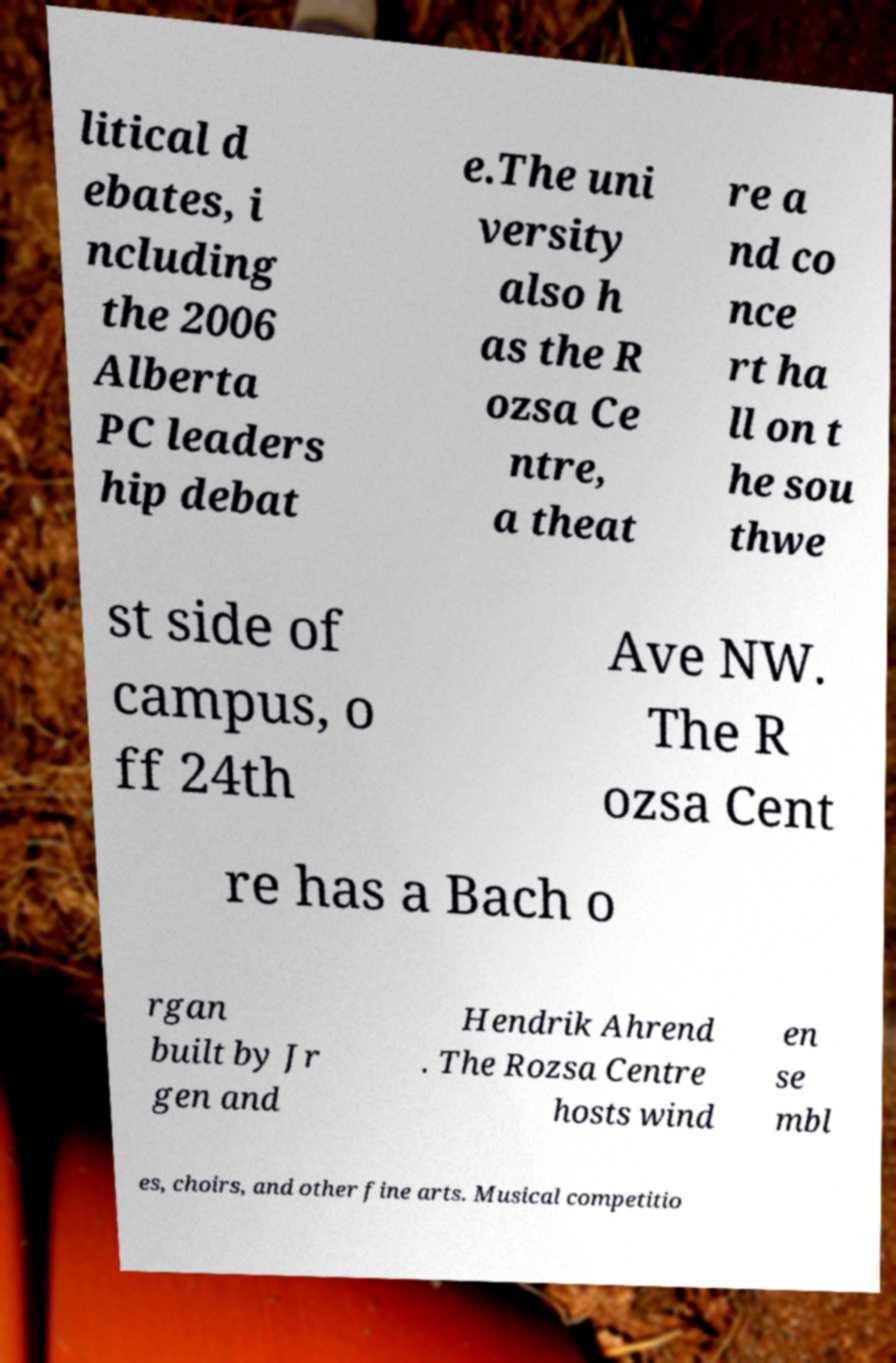Can you accurately transcribe the text from the provided image for me? litical d ebates, i ncluding the 2006 Alberta PC leaders hip debat e.The uni versity also h as the R ozsa Ce ntre, a theat re a nd co nce rt ha ll on t he sou thwe st side of campus, o ff 24th Ave NW. The R ozsa Cent re has a Bach o rgan built by Jr gen and Hendrik Ahrend . The Rozsa Centre hosts wind en se mbl es, choirs, and other fine arts. Musical competitio 